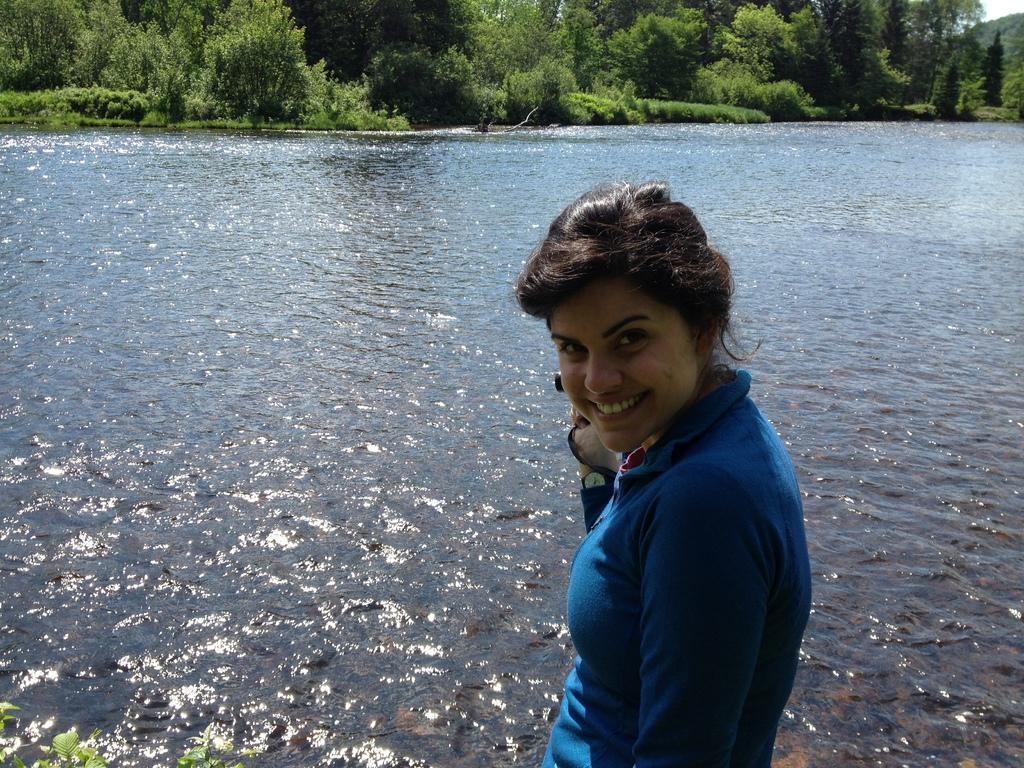Describe this image in one or two sentences. In the picture we can see a woman standing and smiling and she is in blue T-shirt and behind her we can see water and far away from it we can see plants and trees. 